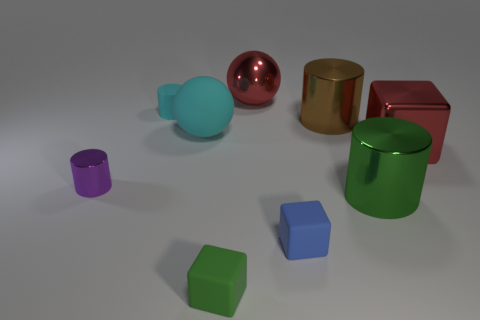Subtract all brown cylinders. How many cylinders are left? 3 Subtract all blue cylinders. Subtract all yellow cubes. How many cylinders are left? 4 Add 1 purple metallic things. How many objects exist? 10 Subtract all spheres. How many objects are left? 7 Subtract 0 purple blocks. How many objects are left? 9 Subtract all small rubber objects. Subtract all green shiny cylinders. How many objects are left? 5 Add 1 brown things. How many brown things are left? 2 Add 3 tiny green rubber balls. How many tiny green rubber balls exist? 3 